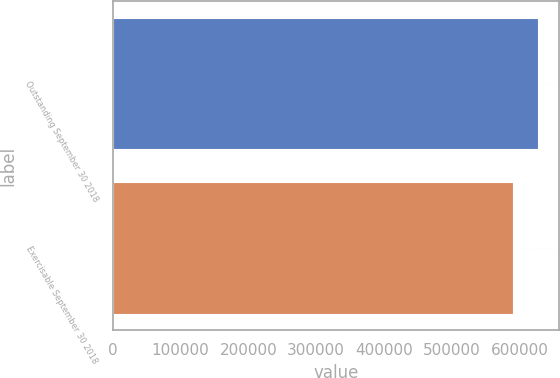Convert chart. <chart><loc_0><loc_0><loc_500><loc_500><bar_chart><fcel>Outstanding September 30 2018<fcel>Exercisable September 30 2018<nl><fcel>626701<fcel>590556<nl></chart> 